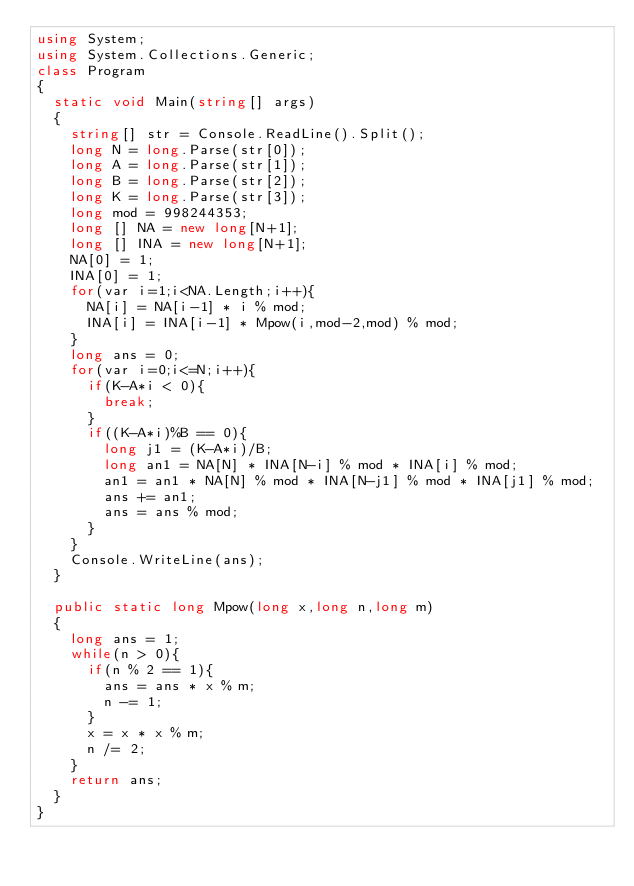Convert code to text. <code><loc_0><loc_0><loc_500><loc_500><_C#_>using System;
using System.Collections.Generic;
class Program
{
	static void Main(string[] args)
	{
		string[] str = Console.ReadLine().Split();
		long N = long.Parse(str[0]);
		long A = long.Parse(str[1]);
		long B = long.Parse(str[2]);
		long K = long.Parse(str[3]);
		long mod = 998244353;
		long [] NA = new long[N+1];
		long [] INA = new long[N+1];
		NA[0] = 1;
		INA[0] = 1;
		for(var i=1;i<NA.Length;i++){
			NA[i] = NA[i-1] * i % mod;
			INA[i] = INA[i-1] * Mpow(i,mod-2,mod) % mod;
		}
		long ans = 0;
		for(var i=0;i<=N;i++){
			if(K-A*i < 0){
				break;
			}
			if((K-A*i)%B == 0){
				long j1 = (K-A*i)/B;
				long an1 = NA[N] * INA[N-i] % mod * INA[i] % mod;
				an1 = an1 * NA[N] % mod * INA[N-j1] % mod * INA[j1] % mod;
				ans += an1;
				ans = ans % mod;
			}
		}
		Console.WriteLine(ans);
	}

	public static long Mpow(long x,long n,long m)
	{
		long ans = 1;
		while(n > 0){
			if(n % 2 == 1){
				ans = ans * x % m;
				n -= 1;
			}
			x = x * x % m;
			n /= 2;
		}
		return ans;
	}
}</code> 